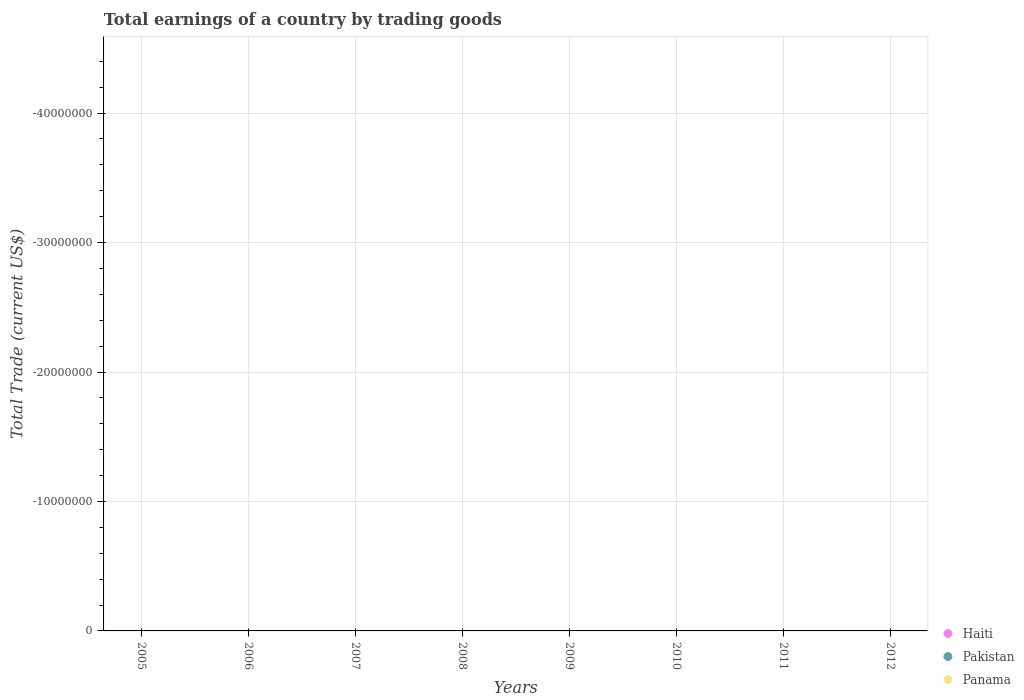How many different coloured dotlines are there?
Keep it short and to the point. 0. What is the total earnings in Panama in 2007?
Make the answer very short. 0. Across all years, what is the minimum total earnings in Panama?
Provide a succinct answer. 0. What is the average total earnings in Haiti per year?
Provide a succinct answer. 0. In how many years, is the total earnings in Panama greater than the average total earnings in Panama taken over all years?
Provide a succinct answer. 0. Is it the case that in every year, the sum of the total earnings in Panama and total earnings in Pakistan  is greater than the total earnings in Haiti?
Offer a very short reply. No. How many dotlines are there?
Offer a very short reply. 0. How many years are there in the graph?
Give a very brief answer. 8. Are the values on the major ticks of Y-axis written in scientific E-notation?
Give a very brief answer. No. Does the graph contain any zero values?
Your response must be concise. Yes. How are the legend labels stacked?
Your answer should be compact. Vertical. What is the title of the graph?
Provide a succinct answer. Total earnings of a country by trading goods. What is the label or title of the X-axis?
Offer a terse response. Years. What is the label or title of the Y-axis?
Provide a succinct answer. Total Trade (current US$). What is the Total Trade (current US$) of Pakistan in 2005?
Your answer should be very brief. 0. What is the Total Trade (current US$) of Panama in 2006?
Give a very brief answer. 0. What is the Total Trade (current US$) in Haiti in 2007?
Your response must be concise. 0. What is the Total Trade (current US$) in Pakistan in 2007?
Your answer should be compact. 0. What is the Total Trade (current US$) in Haiti in 2008?
Keep it short and to the point. 0. What is the Total Trade (current US$) of Pakistan in 2008?
Give a very brief answer. 0. What is the Total Trade (current US$) in Panama in 2008?
Your response must be concise. 0. What is the Total Trade (current US$) of Haiti in 2009?
Keep it short and to the point. 0. What is the Total Trade (current US$) in Pakistan in 2009?
Ensure brevity in your answer.  0. What is the Total Trade (current US$) in Panama in 2009?
Make the answer very short. 0. What is the Total Trade (current US$) of Haiti in 2010?
Make the answer very short. 0. What is the Total Trade (current US$) in Panama in 2010?
Offer a terse response. 0. What is the Total Trade (current US$) of Haiti in 2011?
Offer a terse response. 0. What is the Total Trade (current US$) in Pakistan in 2011?
Your answer should be compact. 0. What is the Total Trade (current US$) of Panama in 2011?
Provide a succinct answer. 0. What is the Total Trade (current US$) of Haiti in 2012?
Provide a short and direct response. 0. What is the Total Trade (current US$) of Pakistan in 2012?
Your answer should be very brief. 0. What is the Total Trade (current US$) of Panama in 2012?
Keep it short and to the point. 0. What is the total Total Trade (current US$) in Pakistan in the graph?
Make the answer very short. 0. What is the total Total Trade (current US$) of Panama in the graph?
Your response must be concise. 0. What is the average Total Trade (current US$) of Haiti per year?
Make the answer very short. 0. What is the average Total Trade (current US$) in Pakistan per year?
Provide a short and direct response. 0. What is the average Total Trade (current US$) in Panama per year?
Your answer should be compact. 0. 